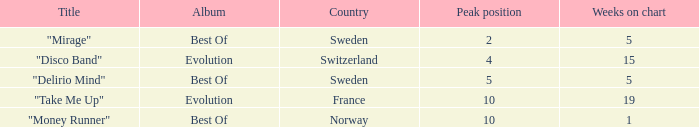What is the most weeks on chart when the peak position is less than 5 and from sweden? 5.0. 